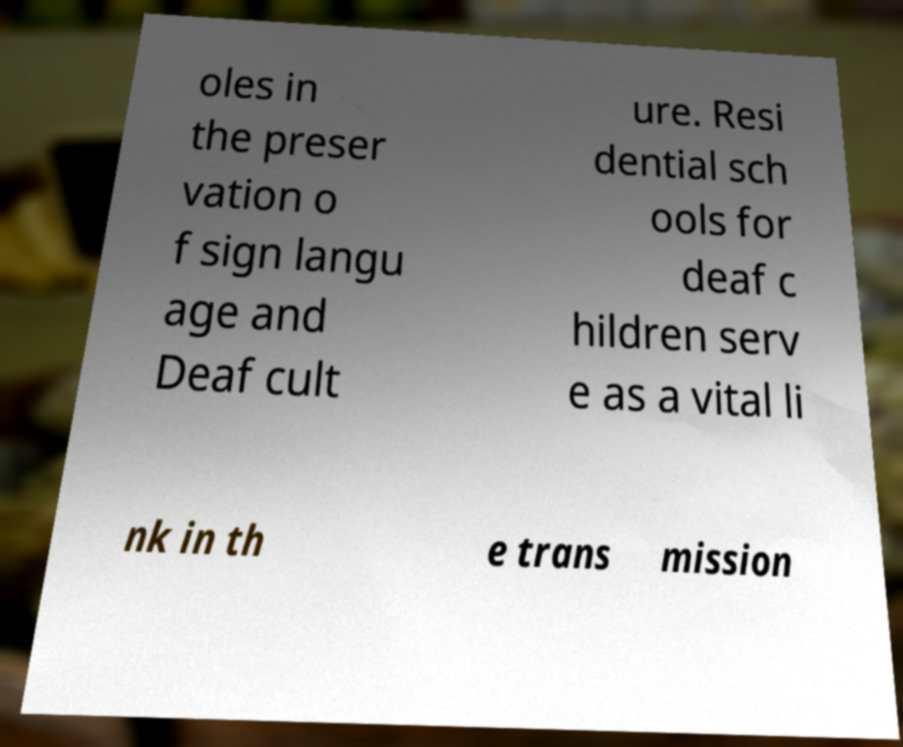Please read and relay the text visible in this image. What does it say? oles in the preser vation o f sign langu age and Deaf cult ure. Resi dential sch ools for deaf c hildren serv e as a vital li nk in th e trans mission 